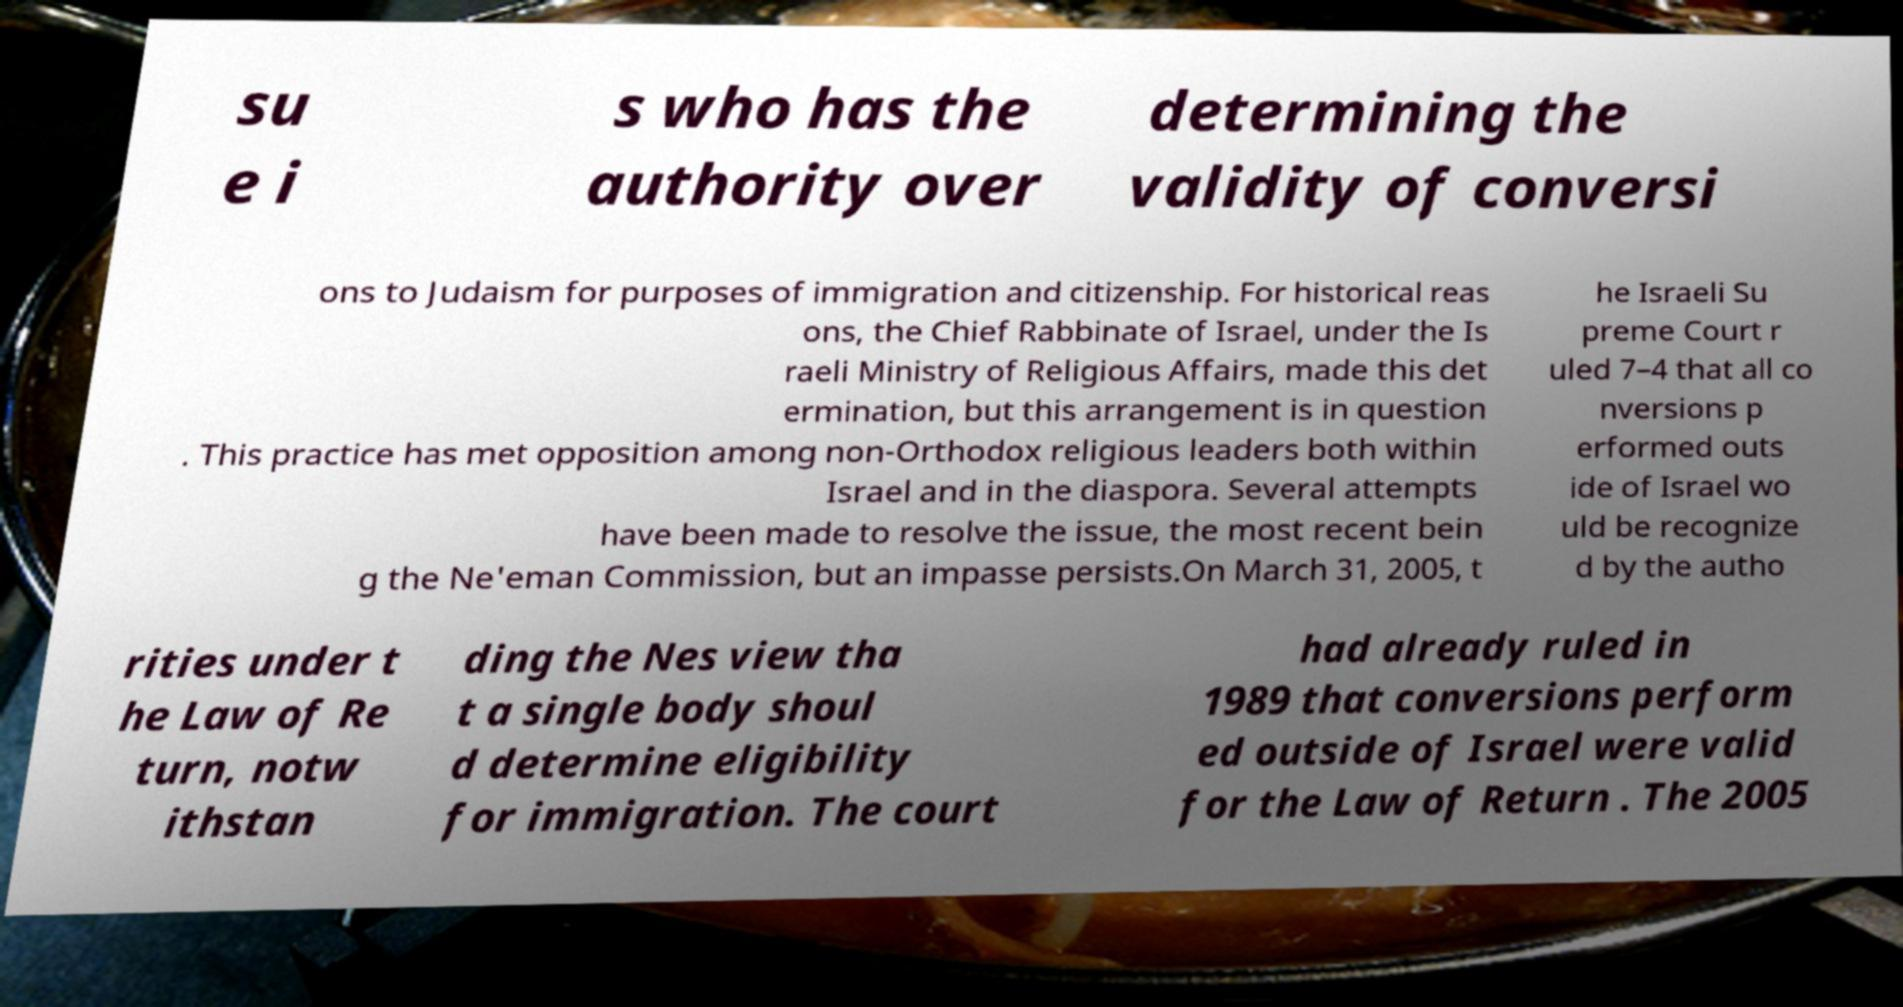Can you accurately transcribe the text from the provided image for me? su e i s who has the authority over determining the validity of conversi ons to Judaism for purposes of immigration and citizenship. For historical reas ons, the Chief Rabbinate of Israel, under the Is raeli Ministry of Religious Affairs, made this det ermination, but this arrangement is in question . This practice has met opposition among non-Orthodox religious leaders both within Israel and in the diaspora. Several attempts have been made to resolve the issue, the most recent bein g the Ne'eman Commission, but an impasse persists.On March 31, 2005, t he Israeli Su preme Court r uled 7–4 that all co nversions p erformed outs ide of Israel wo uld be recognize d by the autho rities under t he Law of Re turn, notw ithstan ding the Nes view tha t a single body shoul d determine eligibility for immigration. The court had already ruled in 1989 that conversions perform ed outside of Israel were valid for the Law of Return . The 2005 